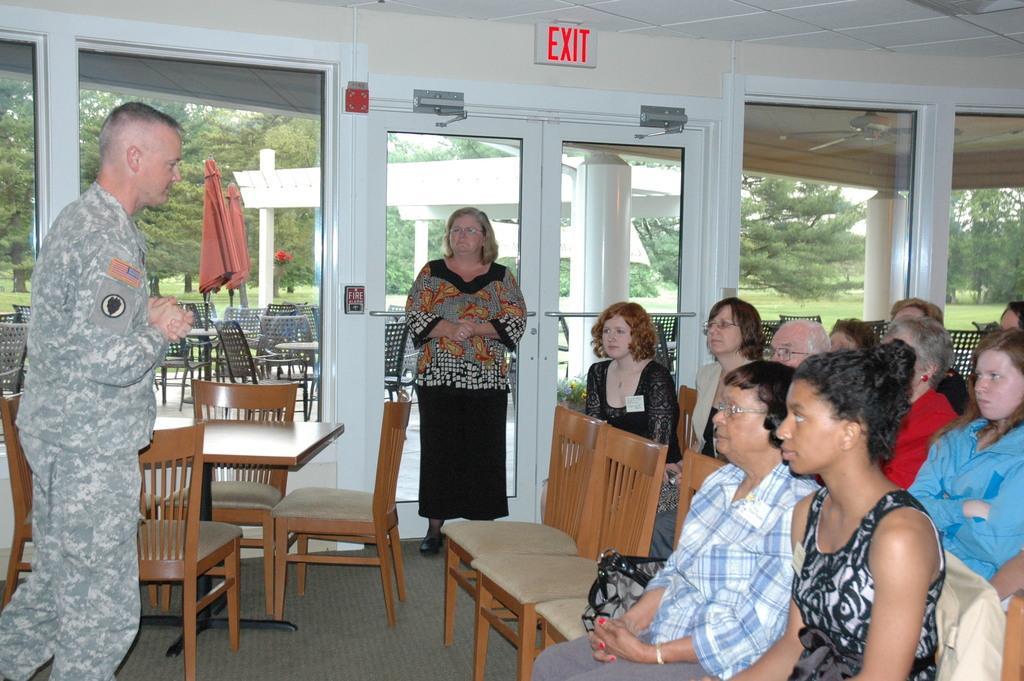How would you summarize this image in a sentence or two? In the image we can see there are people who are sitting on the chair and there are two people who are standing and on the top it's written "EXIT". 